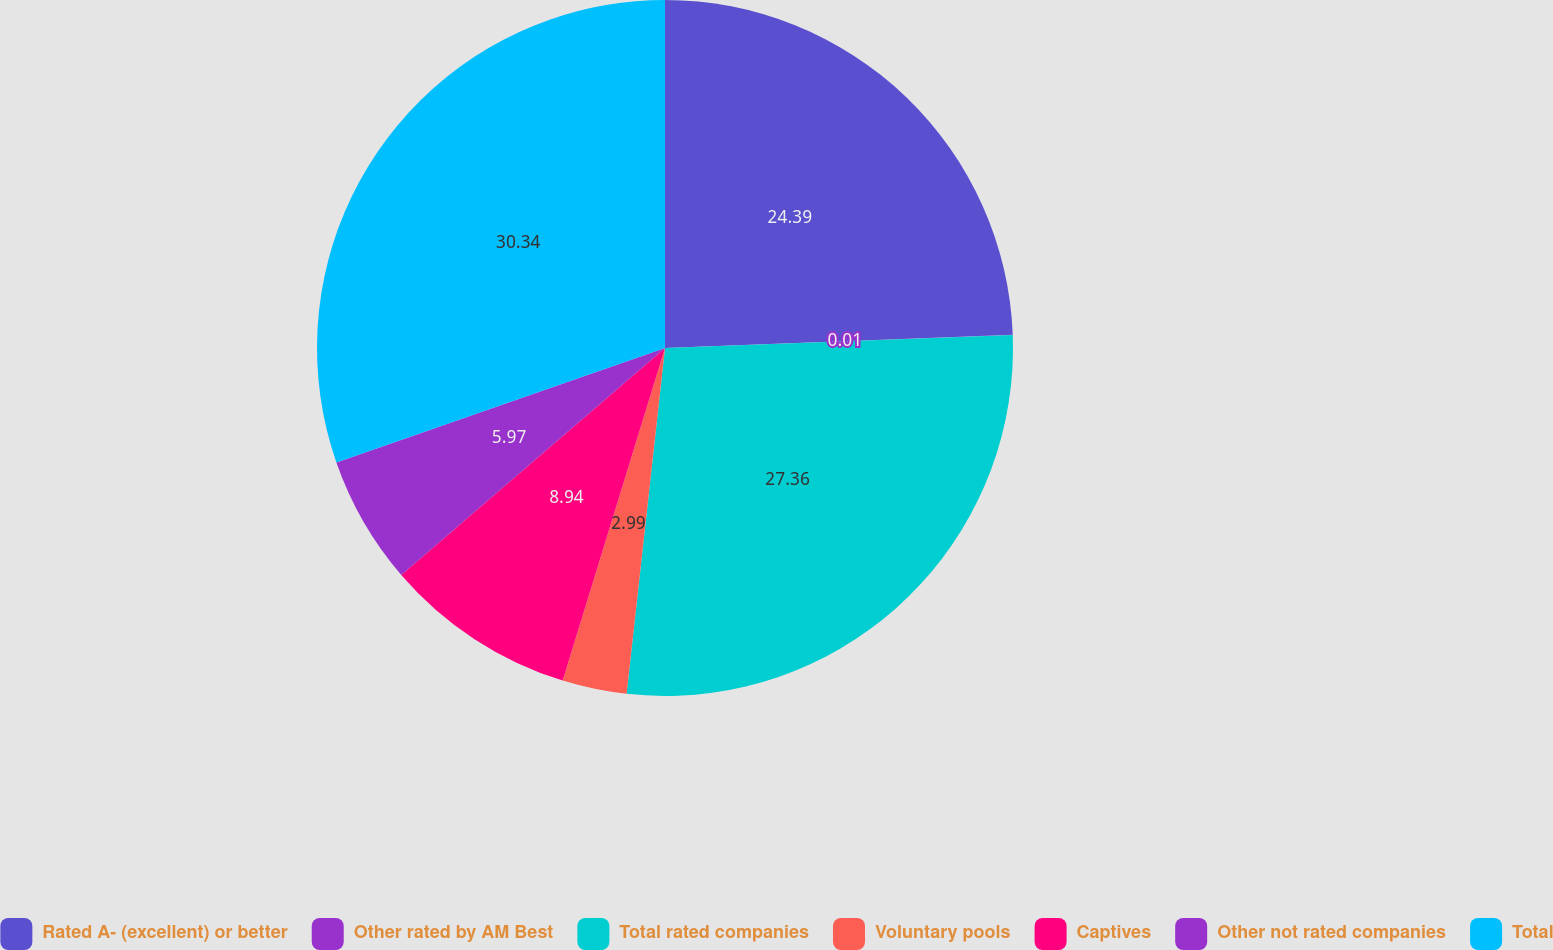Convert chart to OTSL. <chart><loc_0><loc_0><loc_500><loc_500><pie_chart><fcel>Rated A- (excellent) or better<fcel>Other rated by AM Best<fcel>Total rated companies<fcel>Voluntary pools<fcel>Captives<fcel>Other not rated companies<fcel>Total<nl><fcel>24.39%<fcel>0.01%<fcel>27.36%<fcel>2.99%<fcel>8.94%<fcel>5.97%<fcel>30.34%<nl></chart> 